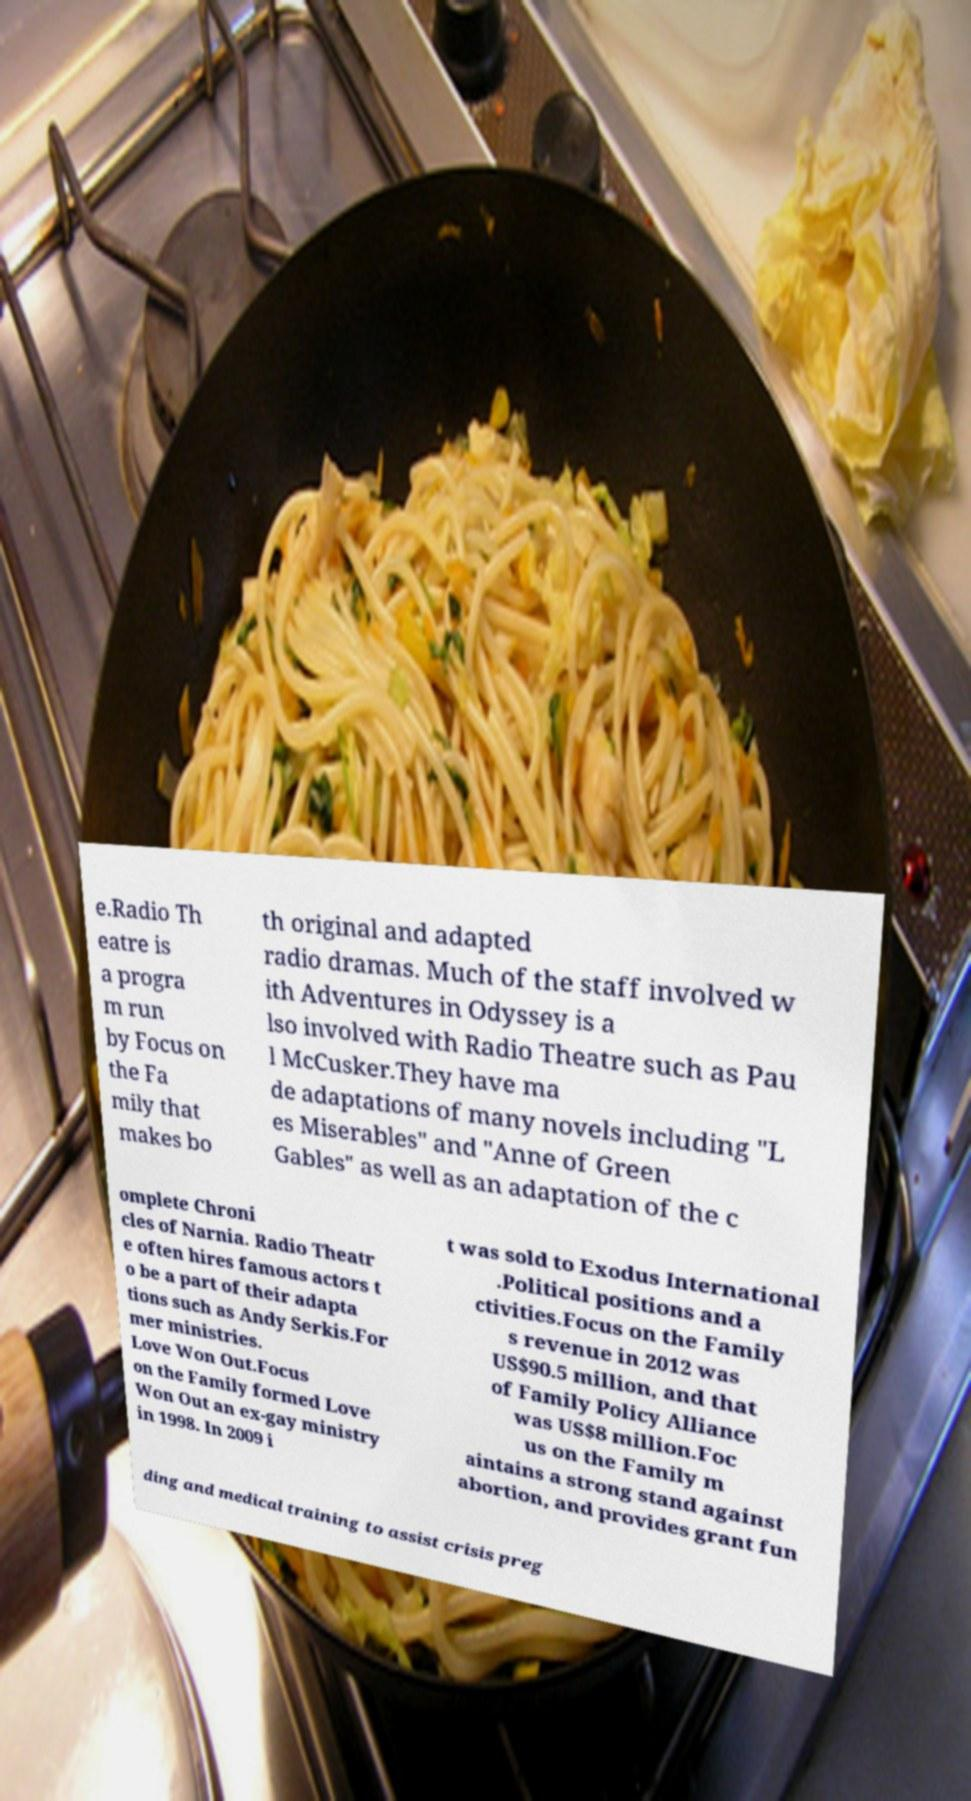What messages or text are displayed in this image? I need them in a readable, typed format. e.Radio Th eatre is a progra m run by Focus on the Fa mily that makes bo th original and adapted radio dramas. Much of the staff involved w ith Adventures in Odyssey is a lso involved with Radio Theatre such as Pau l McCusker.They have ma de adaptations of many novels including "L es Miserables" and "Anne of Green Gables" as well as an adaptation of the c omplete Chroni cles of Narnia. Radio Theatr e often hires famous actors t o be a part of their adapta tions such as Andy Serkis.For mer ministries. Love Won Out.Focus on the Family formed Love Won Out an ex-gay ministry in 1998. In 2009 i t was sold to Exodus International .Political positions and a ctivities.Focus on the Family s revenue in 2012 was US$90.5 million, and that of Family Policy Alliance was US$8 million.Foc us on the Family m aintains a strong stand against abortion, and provides grant fun ding and medical training to assist crisis preg 